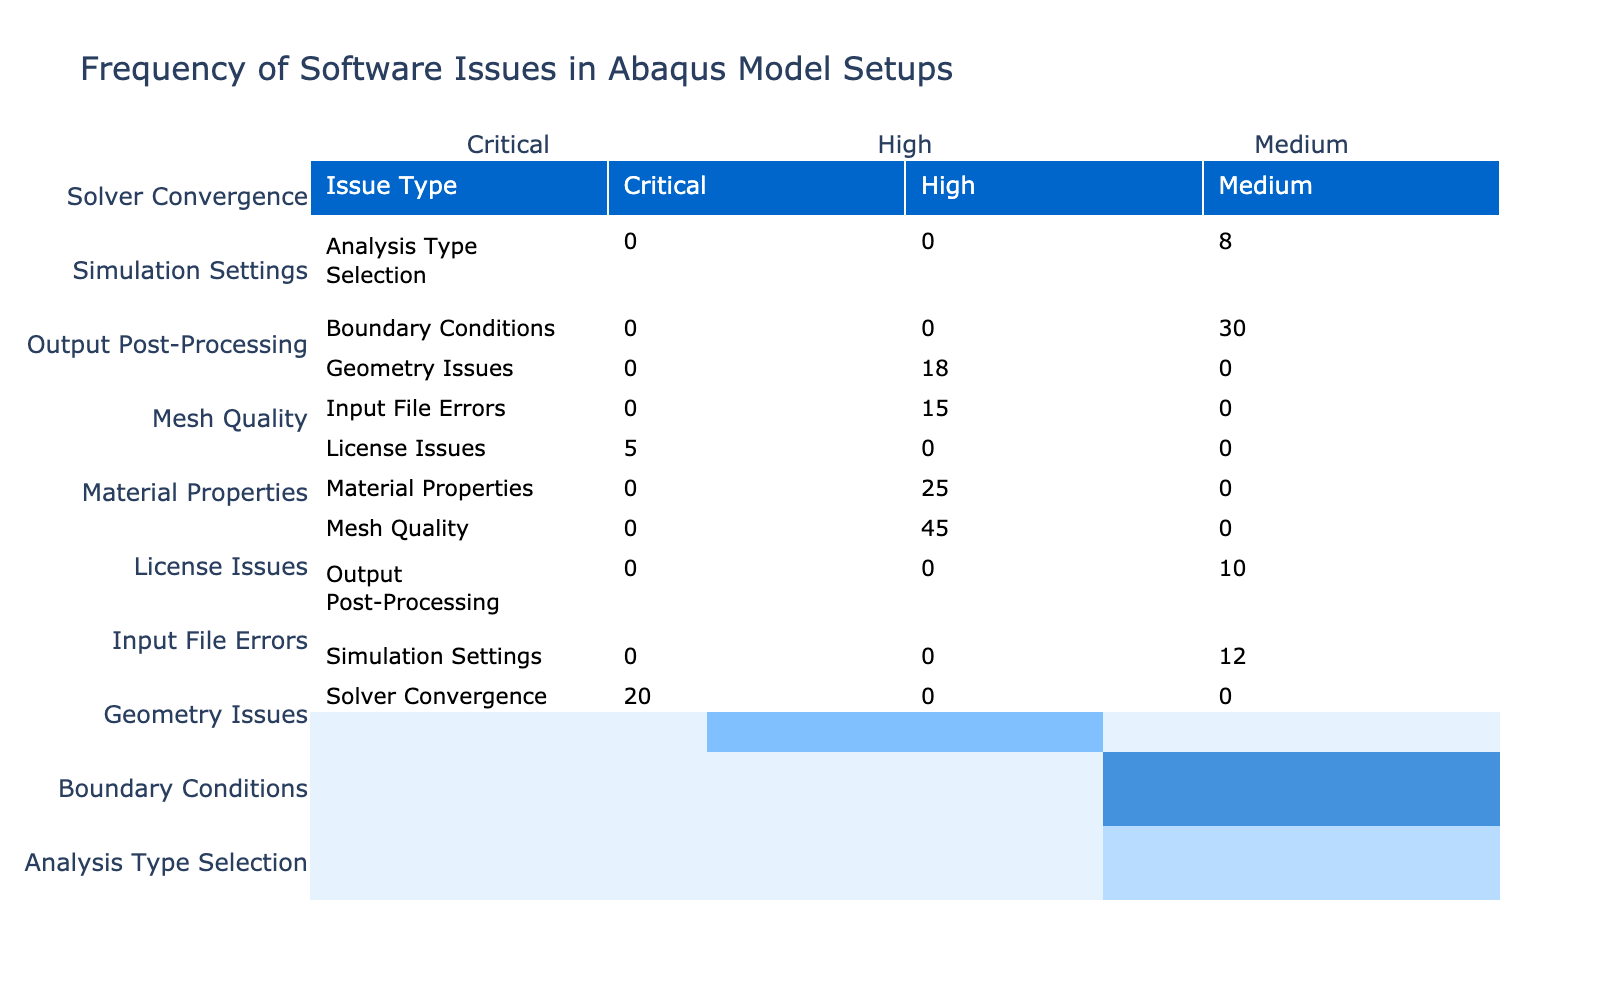What is the frequency of issues categorized as Critical? From the table, we identify the "Solver Convergence" and "License Issues" are marked as Critical. The respective frequencies are 20 and 5. Thus, adding these together gives us 20 + 5 = 25.
Answer: 25 Which issue type has the highest frequency? By inspecting the table, the issue type "Mesh Quality" has the highest frequency value of 45 when compared to other issues.
Answer: Mesh Quality What is the total frequency of Medium severity issues? The Medium severity issues listed are "Boundary Conditions" (30), "Output Post-Processing" (10), and "Simulation Settings" (12). Adding these frequencies, we have 30 + 10 + 12 = 52 as the total frequency for Medium severity issues.
Answer: 52 Is there any issue type with zero frequency? Reviewing the table, all listed issue types have associated frequencies, so none have a frequency of zero.
Answer: No What is the average frequency of issues classified as High severity? The High severity issues present are "Mesh Quality" (45), "Material Properties" (25), "Input File Errors" (15), and "Geometry Issues" (18). Summing these yields 45 + 25 + 15 + 18 = 103. Dividing by the number of High severity issues, which are 4, gives us an average of 103 / 4 = 25.75.
Answer: 25.75 How many more issues of High severity exist compared to Medium severity? There are four High severity issues: "Mesh Quality," "Material Properties," "Input File Errors," and "Geometry Issues," which total 45 + 25 + 15 + 18 = 103. For Medium severity, there are three issues: "Boundary Conditions," "Output Post-Processing," and "Simulation Settings," totaling 30 + 10 + 12 = 52. To find the difference, we calculate 103 - 52 = 51.
Answer: 51 Which severity level has the least number of issues? Checking the table, we see that Critical severity has only 2 issue types ("Solver Convergence" and "License Issues"), while other severity levels have at least 3 issues each.
Answer: Critical What is the frequency difference between the highest and lowest issue frequency? The highest frequency is 45 (Mesh Quality) and the lowest is 5 (License Issues). Calculating the difference, 45 - 5 = 40.
Answer: 40 